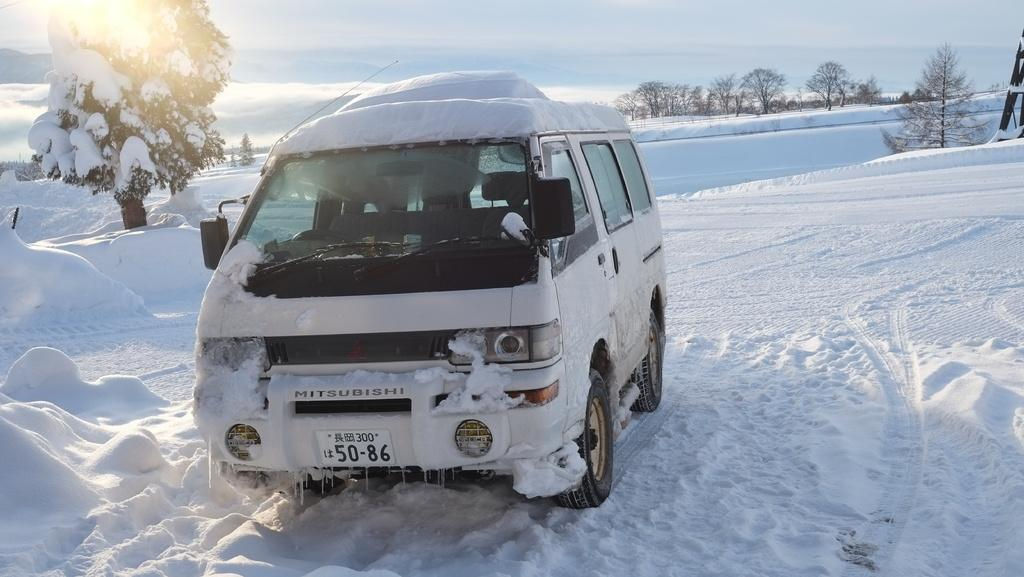What is the color of the vehicle in the image? The vehicle in the image is white. Does the vehicle have any identifying features? Yes, the vehicle has a registration plate. What is the terrain under the vehicle? The vehicle is on snow. What type of vegetation can be seen in the image? There are trees in the image. What is visible in the background of the image? The sky with clouds is visible in the background. What type of doll is sitting on the fork in the image? There is no doll or fork present in the image. 